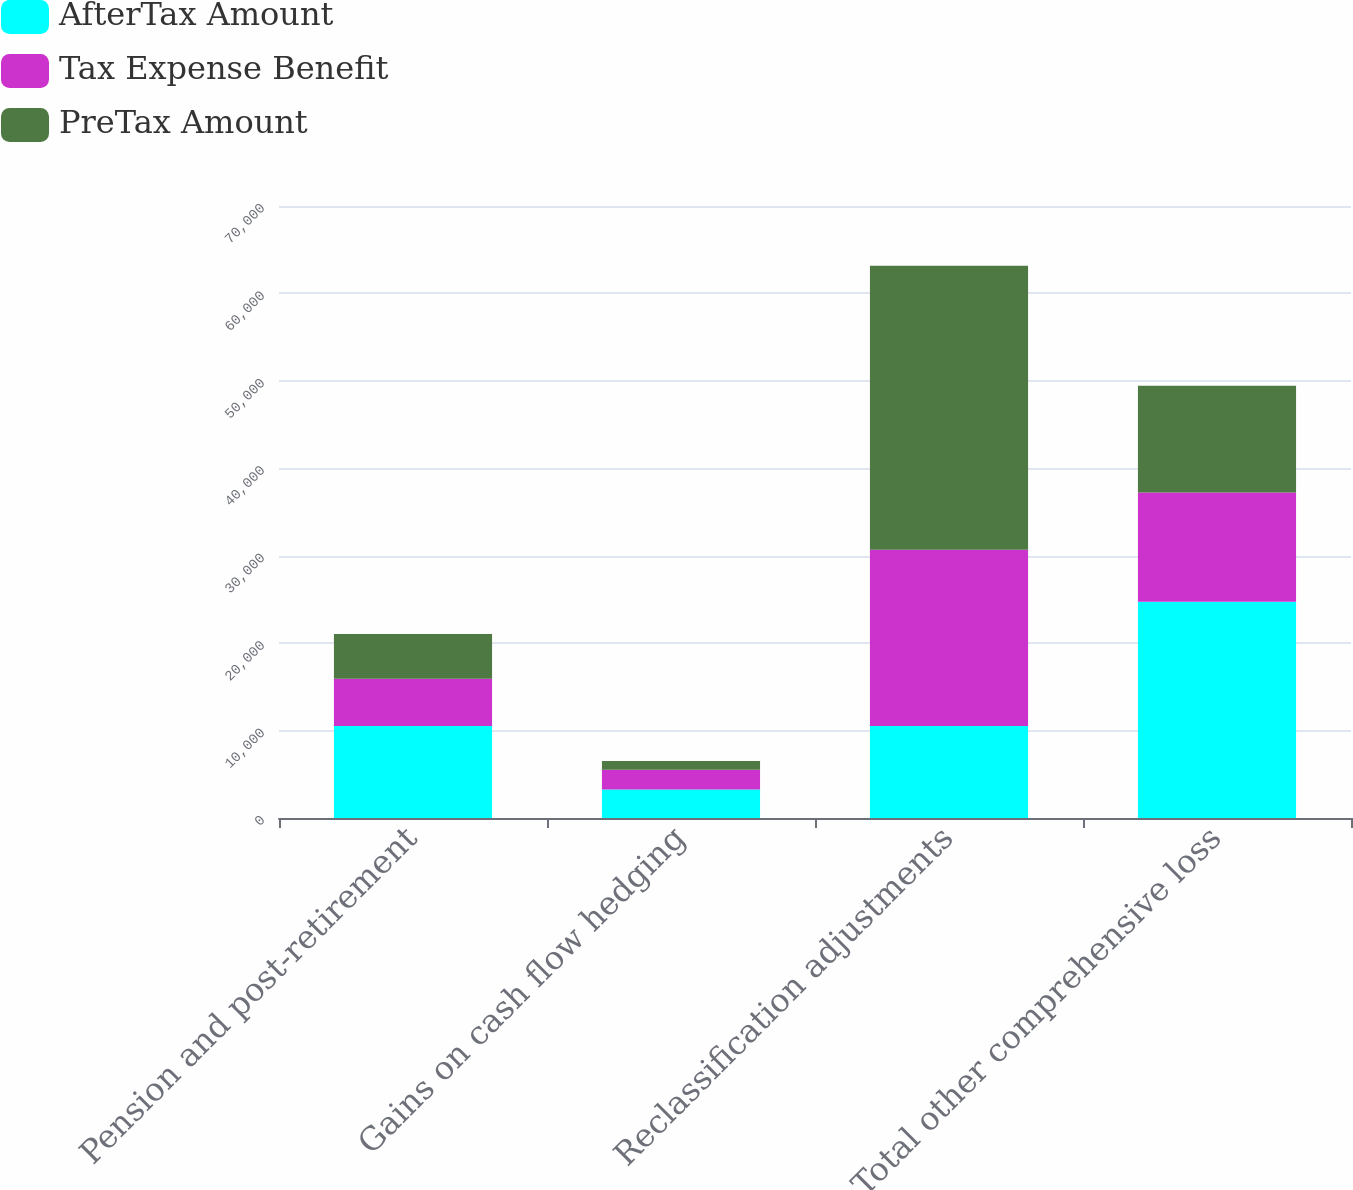<chart> <loc_0><loc_0><loc_500><loc_500><stacked_bar_chart><ecel><fcel>Pension and post-retirement<fcel>Gains on cash flow hedging<fcel>Reclassification adjustments<fcel>Total other comprehensive loss<nl><fcel>AfterTax Amount<fcel>10529<fcel>3260<fcel>10529<fcel>24722<nl><fcel>Tax Expense Benefit<fcel>5399<fcel>2259<fcel>20157<fcel>12499<nl><fcel>PreTax Amount<fcel>5130<fcel>1001<fcel>32477<fcel>12223<nl></chart> 